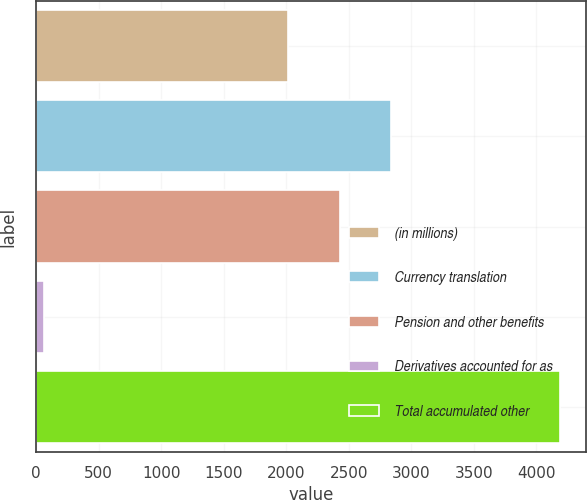Convert chart to OTSL. <chart><loc_0><loc_0><loc_500><loc_500><bar_chart><fcel>(in millions)<fcel>Currency translation<fcel>Pension and other benefits<fcel>Derivatives accounted for as<fcel>Total accumulated other<nl><fcel>2013<fcel>2838.4<fcel>2425.7<fcel>63<fcel>4190<nl></chart> 